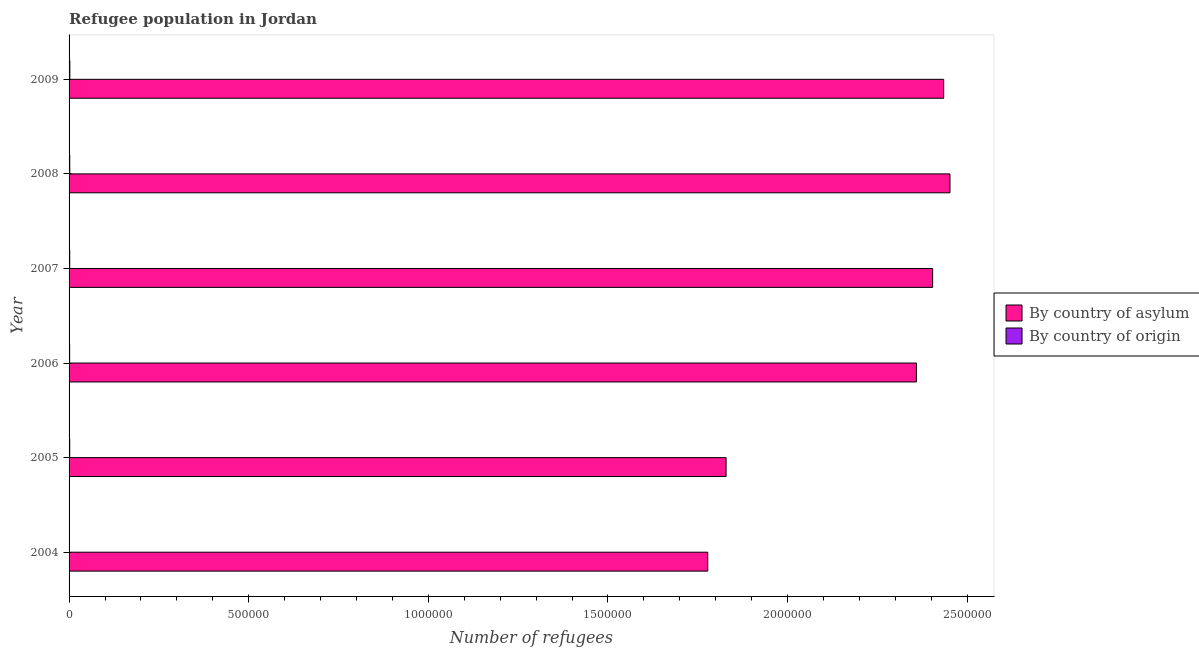Are the number of bars per tick equal to the number of legend labels?
Keep it short and to the point. Yes. Are the number of bars on each tick of the Y-axis equal?
Your response must be concise. Yes. What is the label of the 5th group of bars from the top?
Your response must be concise. 2005. In how many cases, is the number of bars for a given year not equal to the number of legend labels?
Your answer should be compact. 0. What is the number of refugees by country of origin in 2005?
Make the answer very short. 1789. Across all years, what is the maximum number of refugees by country of asylum?
Your response must be concise. 2.45e+06. Across all years, what is the minimum number of refugees by country of origin?
Make the answer very short. 1169. What is the total number of refugees by country of origin in the graph?
Provide a short and direct response. 1.04e+04. What is the difference between the number of refugees by country of origin in 2006 and that in 2008?
Keep it short and to the point. -286. What is the difference between the number of refugees by country of asylum in 2007 and the number of refugees by country of origin in 2005?
Offer a terse response. 2.40e+06. What is the average number of refugees by country of asylum per year?
Offer a very short reply. 2.21e+06. In the year 2009, what is the difference between the number of refugees by country of origin and number of refugees by country of asylum?
Keep it short and to the point. -2.43e+06. In how many years, is the number of refugees by country of asylum greater than 1500000 ?
Make the answer very short. 6. Is the number of refugees by country of asylum in 2007 less than that in 2009?
Your answer should be compact. Yes. What is the difference between the highest and the second highest number of refugees by country of asylum?
Offer a very short reply. 1.75e+04. What is the difference between the highest and the lowest number of refugees by country of origin?
Offer a terse response. 960. Is the sum of the number of refugees by country of origin in 2006 and 2008 greater than the maximum number of refugees by country of asylum across all years?
Keep it short and to the point. No. What does the 1st bar from the top in 2005 represents?
Provide a short and direct response. By country of origin. What does the 1st bar from the bottom in 2005 represents?
Offer a terse response. By country of asylum. How many bars are there?
Keep it short and to the point. 12. What is the difference between two consecutive major ticks on the X-axis?
Your answer should be compact. 5.00e+05. Are the values on the major ticks of X-axis written in scientific E-notation?
Give a very brief answer. No. Where does the legend appear in the graph?
Your response must be concise. Center right. What is the title of the graph?
Give a very brief answer. Refugee population in Jordan. Does "Non-resident workers" appear as one of the legend labels in the graph?
Offer a terse response. No. What is the label or title of the X-axis?
Your answer should be compact. Number of refugees. What is the Number of refugees in By country of asylum in 2004?
Provide a succinct answer. 1.78e+06. What is the Number of refugees in By country of origin in 2004?
Your response must be concise. 1169. What is the Number of refugees of By country of asylum in 2005?
Keep it short and to the point. 1.83e+06. What is the Number of refugees of By country of origin in 2005?
Your answer should be compact. 1789. What is the Number of refugees of By country of asylum in 2006?
Your response must be concise. 2.36e+06. What is the Number of refugees in By country of origin in 2006?
Your response must be concise. 1604. What is the Number of refugees in By country of asylum in 2007?
Make the answer very short. 2.40e+06. What is the Number of refugees of By country of origin in 2007?
Your answer should be compact. 1787. What is the Number of refugees of By country of asylum in 2008?
Keep it short and to the point. 2.45e+06. What is the Number of refugees in By country of origin in 2008?
Offer a terse response. 1890. What is the Number of refugees in By country of asylum in 2009?
Your answer should be very brief. 2.43e+06. What is the Number of refugees of By country of origin in 2009?
Your response must be concise. 2129. Across all years, what is the maximum Number of refugees in By country of asylum?
Keep it short and to the point. 2.45e+06. Across all years, what is the maximum Number of refugees of By country of origin?
Give a very brief answer. 2129. Across all years, what is the minimum Number of refugees of By country of asylum?
Ensure brevity in your answer.  1.78e+06. Across all years, what is the minimum Number of refugees in By country of origin?
Offer a very short reply. 1169. What is the total Number of refugees of By country of asylum in the graph?
Your answer should be compact. 1.33e+07. What is the total Number of refugees of By country of origin in the graph?
Your answer should be compact. 1.04e+04. What is the difference between the Number of refugees of By country of asylum in 2004 and that in 2005?
Ensure brevity in your answer.  -5.11e+04. What is the difference between the Number of refugees of By country of origin in 2004 and that in 2005?
Offer a very short reply. -620. What is the difference between the Number of refugees of By country of asylum in 2004 and that in 2006?
Provide a short and direct response. -5.81e+05. What is the difference between the Number of refugees of By country of origin in 2004 and that in 2006?
Keep it short and to the point. -435. What is the difference between the Number of refugees of By country of asylum in 2004 and that in 2007?
Your answer should be compact. -6.26e+05. What is the difference between the Number of refugees of By country of origin in 2004 and that in 2007?
Your response must be concise. -618. What is the difference between the Number of refugees in By country of asylum in 2004 and that in 2008?
Offer a very short reply. -6.74e+05. What is the difference between the Number of refugees in By country of origin in 2004 and that in 2008?
Provide a succinct answer. -721. What is the difference between the Number of refugees of By country of asylum in 2004 and that in 2009?
Ensure brevity in your answer.  -6.57e+05. What is the difference between the Number of refugees in By country of origin in 2004 and that in 2009?
Provide a succinct answer. -960. What is the difference between the Number of refugees in By country of asylum in 2005 and that in 2006?
Ensure brevity in your answer.  -5.30e+05. What is the difference between the Number of refugees in By country of origin in 2005 and that in 2006?
Offer a terse response. 185. What is the difference between the Number of refugees in By country of asylum in 2005 and that in 2007?
Provide a short and direct response. -5.75e+05. What is the difference between the Number of refugees in By country of origin in 2005 and that in 2007?
Provide a short and direct response. 2. What is the difference between the Number of refugees of By country of asylum in 2005 and that in 2008?
Ensure brevity in your answer.  -6.23e+05. What is the difference between the Number of refugees of By country of origin in 2005 and that in 2008?
Your answer should be very brief. -101. What is the difference between the Number of refugees in By country of asylum in 2005 and that in 2009?
Make the answer very short. -6.06e+05. What is the difference between the Number of refugees in By country of origin in 2005 and that in 2009?
Ensure brevity in your answer.  -340. What is the difference between the Number of refugees in By country of asylum in 2006 and that in 2007?
Your response must be concise. -4.52e+04. What is the difference between the Number of refugees in By country of origin in 2006 and that in 2007?
Your response must be concise. -183. What is the difference between the Number of refugees of By country of asylum in 2006 and that in 2008?
Give a very brief answer. -9.34e+04. What is the difference between the Number of refugees in By country of origin in 2006 and that in 2008?
Make the answer very short. -286. What is the difference between the Number of refugees of By country of asylum in 2006 and that in 2009?
Ensure brevity in your answer.  -7.59e+04. What is the difference between the Number of refugees in By country of origin in 2006 and that in 2009?
Your answer should be compact. -525. What is the difference between the Number of refugees in By country of asylum in 2007 and that in 2008?
Provide a succinct answer. -4.82e+04. What is the difference between the Number of refugees in By country of origin in 2007 and that in 2008?
Keep it short and to the point. -103. What is the difference between the Number of refugees of By country of asylum in 2007 and that in 2009?
Keep it short and to the point. -3.07e+04. What is the difference between the Number of refugees of By country of origin in 2007 and that in 2009?
Keep it short and to the point. -342. What is the difference between the Number of refugees in By country of asylum in 2008 and that in 2009?
Give a very brief answer. 1.75e+04. What is the difference between the Number of refugees in By country of origin in 2008 and that in 2009?
Give a very brief answer. -239. What is the difference between the Number of refugees in By country of asylum in 2004 and the Number of refugees in By country of origin in 2005?
Your answer should be very brief. 1.78e+06. What is the difference between the Number of refugees of By country of asylum in 2004 and the Number of refugees of By country of origin in 2006?
Provide a short and direct response. 1.78e+06. What is the difference between the Number of refugees in By country of asylum in 2004 and the Number of refugees in By country of origin in 2007?
Offer a very short reply. 1.78e+06. What is the difference between the Number of refugees in By country of asylum in 2004 and the Number of refugees in By country of origin in 2008?
Make the answer very short. 1.78e+06. What is the difference between the Number of refugees of By country of asylum in 2004 and the Number of refugees of By country of origin in 2009?
Your response must be concise. 1.78e+06. What is the difference between the Number of refugees in By country of asylum in 2005 and the Number of refugees in By country of origin in 2006?
Provide a succinct answer. 1.83e+06. What is the difference between the Number of refugees in By country of asylum in 2005 and the Number of refugees in By country of origin in 2007?
Your answer should be very brief. 1.83e+06. What is the difference between the Number of refugees of By country of asylum in 2005 and the Number of refugees of By country of origin in 2008?
Provide a short and direct response. 1.83e+06. What is the difference between the Number of refugees in By country of asylum in 2005 and the Number of refugees in By country of origin in 2009?
Your answer should be very brief. 1.83e+06. What is the difference between the Number of refugees in By country of asylum in 2006 and the Number of refugees in By country of origin in 2007?
Make the answer very short. 2.36e+06. What is the difference between the Number of refugees in By country of asylum in 2006 and the Number of refugees in By country of origin in 2008?
Offer a terse response. 2.36e+06. What is the difference between the Number of refugees of By country of asylum in 2006 and the Number of refugees of By country of origin in 2009?
Give a very brief answer. 2.36e+06. What is the difference between the Number of refugees in By country of asylum in 2007 and the Number of refugees in By country of origin in 2008?
Keep it short and to the point. 2.40e+06. What is the difference between the Number of refugees in By country of asylum in 2007 and the Number of refugees in By country of origin in 2009?
Offer a very short reply. 2.40e+06. What is the difference between the Number of refugees of By country of asylum in 2008 and the Number of refugees of By country of origin in 2009?
Give a very brief answer. 2.45e+06. What is the average Number of refugees in By country of asylum per year?
Your answer should be compact. 2.21e+06. What is the average Number of refugees in By country of origin per year?
Offer a terse response. 1728. In the year 2004, what is the difference between the Number of refugees of By country of asylum and Number of refugees of By country of origin?
Your answer should be compact. 1.78e+06. In the year 2005, what is the difference between the Number of refugees of By country of asylum and Number of refugees of By country of origin?
Your response must be concise. 1.83e+06. In the year 2006, what is the difference between the Number of refugees of By country of asylum and Number of refugees of By country of origin?
Your answer should be compact. 2.36e+06. In the year 2007, what is the difference between the Number of refugees in By country of asylum and Number of refugees in By country of origin?
Your response must be concise. 2.40e+06. In the year 2008, what is the difference between the Number of refugees of By country of asylum and Number of refugees of By country of origin?
Your response must be concise. 2.45e+06. In the year 2009, what is the difference between the Number of refugees in By country of asylum and Number of refugees in By country of origin?
Make the answer very short. 2.43e+06. What is the ratio of the Number of refugees of By country of asylum in 2004 to that in 2005?
Give a very brief answer. 0.97. What is the ratio of the Number of refugees in By country of origin in 2004 to that in 2005?
Give a very brief answer. 0.65. What is the ratio of the Number of refugees in By country of asylum in 2004 to that in 2006?
Provide a succinct answer. 0.75. What is the ratio of the Number of refugees in By country of origin in 2004 to that in 2006?
Provide a succinct answer. 0.73. What is the ratio of the Number of refugees in By country of asylum in 2004 to that in 2007?
Offer a very short reply. 0.74. What is the ratio of the Number of refugees of By country of origin in 2004 to that in 2007?
Keep it short and to the point. 0.65. What is the ratio of the Number of refugees of By country of asylum in 2004 to that in 2008?
Give a very brief answer. 0.72. What is the ratio of the Number of refugees of By country of origin in 2004 to that in 2008?
Give a very brief answer. 0.62. What is the ratio of the Number of refugees of By country of asylum in 2004 to that in 2009?
Offer a terse response. 0.73. What is the ratio of the Number of refugees of By country of origin in 2004 to that in 2009?
Your response must be concise. 0.55. What is the ratio of the Number of refugees of By country of asylum in 2005 to that in 2006?
Keep it short and to the point. 0.78. What is the ratio of the Number of refugees in By country of origin in 2005 to that in 2006?
Offer a terse response. 1.12. What is the ratio of the Number of refugees of By country of asylum in 2005 to that in 2007?
Your answer should be very brief. 0.76. What is the ratio of the Number of refugees in By country of asylum in 2005 to that in 2008?
Provide a short and direct response. 0.75. What is the ratio of the Number of refugees in By country of origin in 2005 to that in 2008?
Ensure brevity in your answer.  0.95. What is the ratio of the Number of refugees of By country of asylum in 2005 to that in 2009?
Ensure brevity in your answer.  0.75. What is the ratio of the Number of refugees in By country of origin in 2005 to that in 2009?
Provide a short and direct response. 0.84. What is the ratio of the Number of refugees in By country of asylum in 2006 to that in 2007?
Offer a very short reply. 0.98. What is the ratio of the Number of refugees of By country of origin in 2006 to that in 2007?
Offer a terse response. 0.9. What is the ratio of the Number of refugees in By country of asylum in 2006 to that in 2008?
Offer a terse response. 0.96. What is the ratio of the Number of refugees of By country of origin in 2006 to that in 2008?
Your answer should be compact. 0.85. What is the ratio of the Number of refugees in By country of asylum in 2006 to that in 2009?
Offer a very short reply. 0.97. What is the ratio of the Number of refugees in By country of origin in 2006 to that in 2009?
Keep it short and to the point. 0.75. What is the ratio of the Number of refugees of By country of asylum in 2007 to that in 2008?
Your answer should be very brief. 0.98. What is the ratio of the Number of refugees of By country of origin in 2007 to that in 2008?
Your answer should be very brief. 0.95. What is the ratio of the Number of refugees of By country of asylum in 2007 to that in 2009?
Your response must be concise. 0.99. What is the ratio of the Number of refugees in By country of origin in 2007 to that in 2009?
Offer a terse response. 0.84. What is the ratio of the Number of refugees in By country of origin in 2008 to that in 2009?
Your answer should be compact. 0.89. What is the difference between the highest and the second highest Number of refugees of By country of asylum?
Ensure brevity in your answer.  1.75e+04. What is the difference between the highest and the second highest Number of refugees of By country of origin?
Provide a succinct answer. 239. What is the difference between the highest and the lowest Number of refugees in By country of asylum?
Your response must be concise. 6.74e+05. What is the difference between the highest and the lowest Number of refugees of By country of origin?
Provide a short and direct response. 960. 